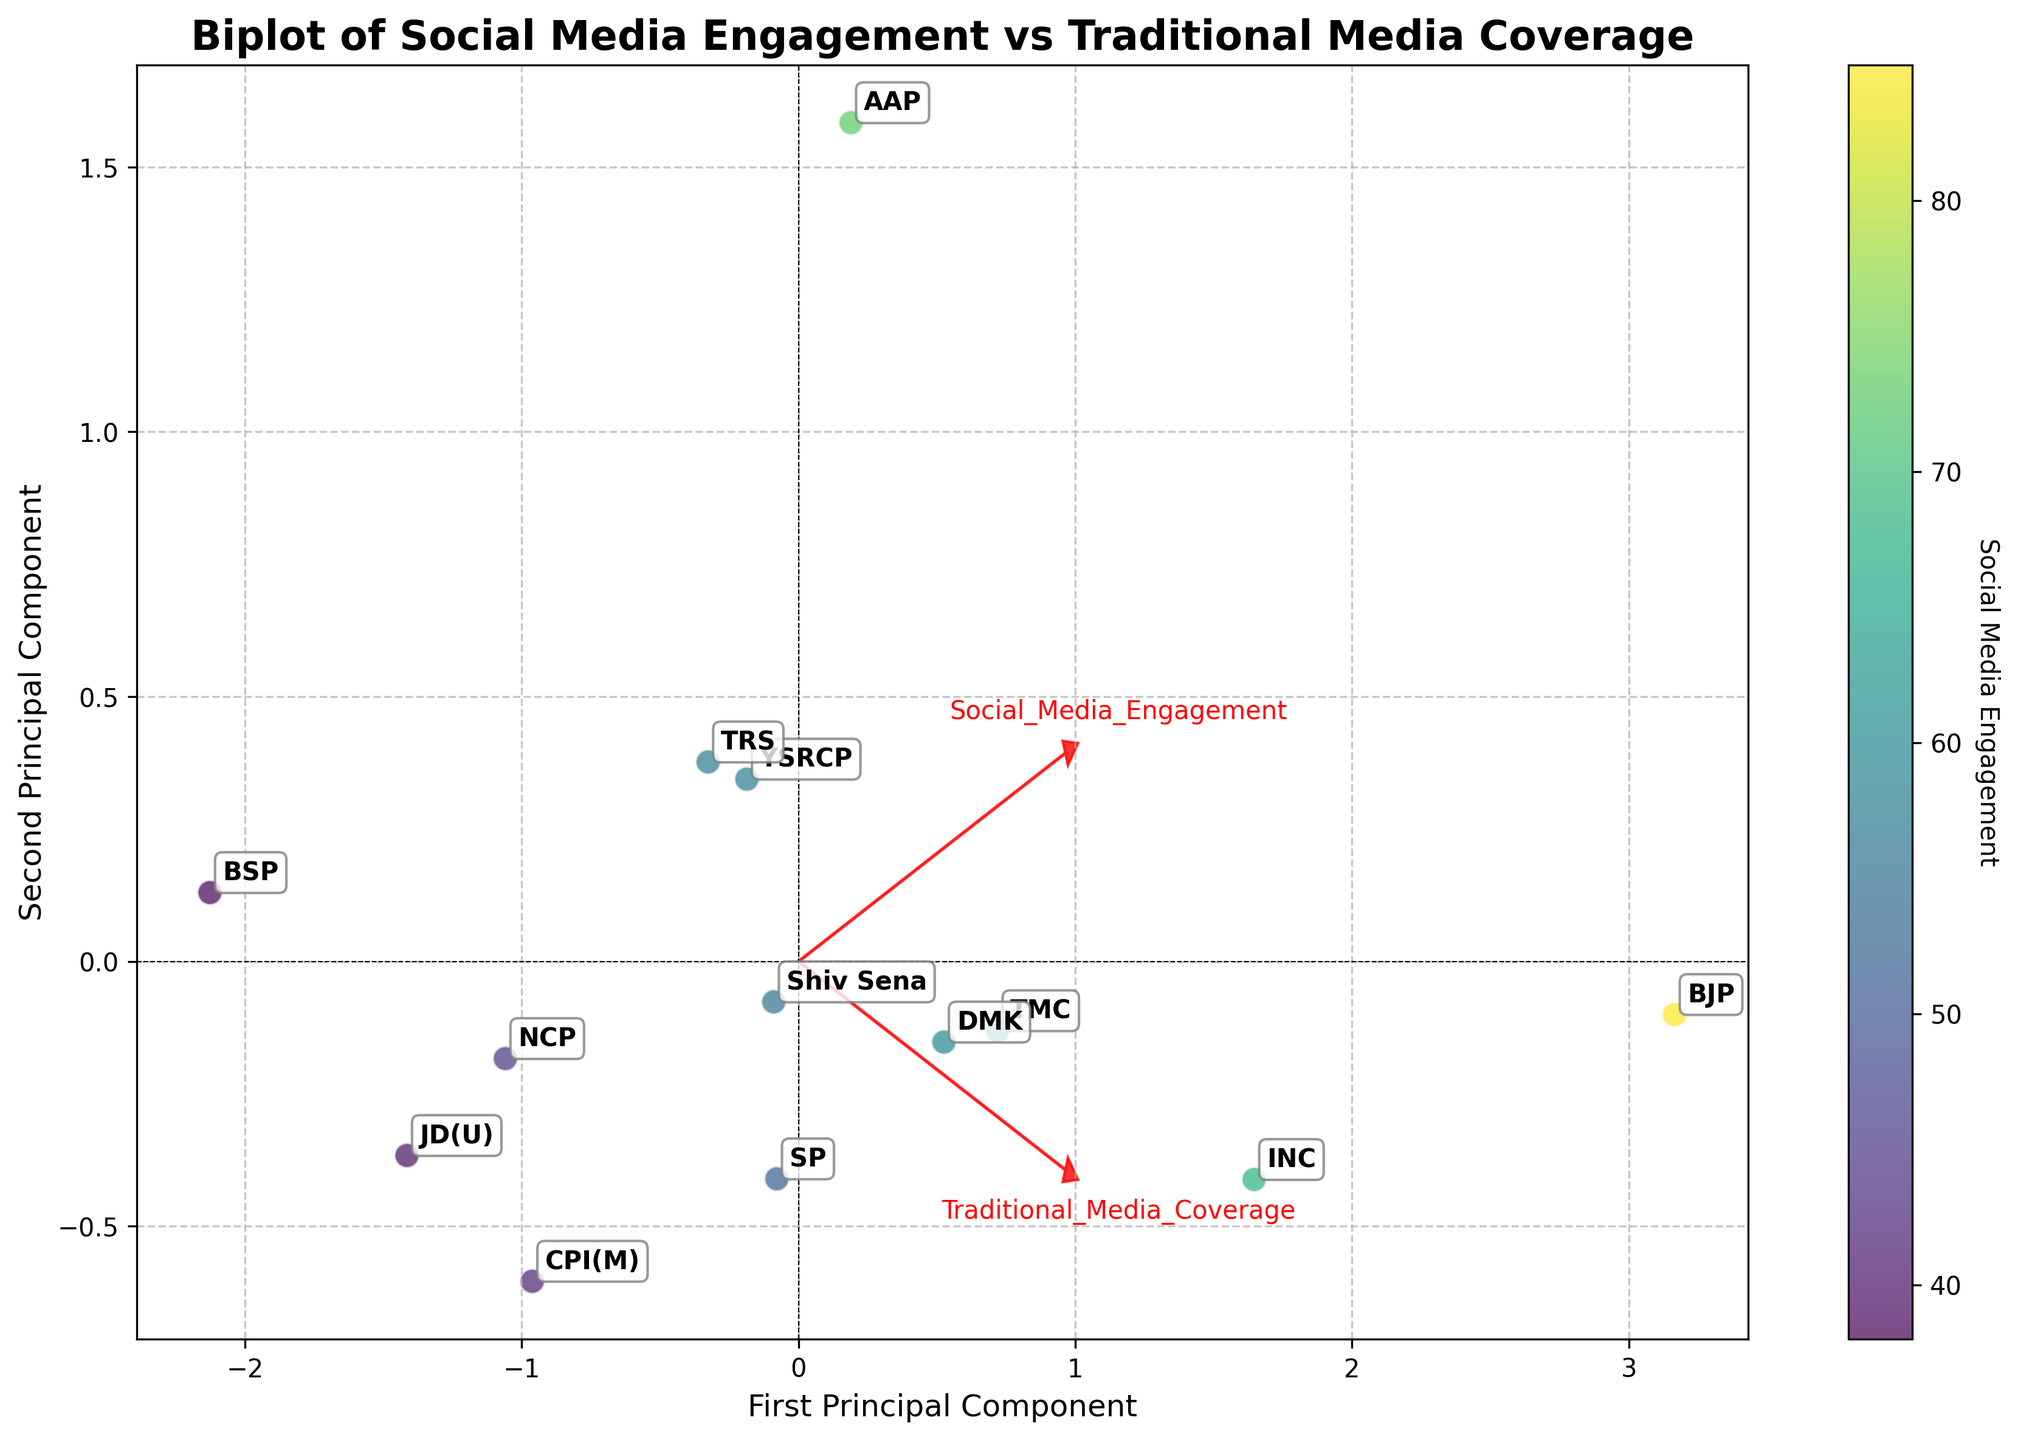What's the title of the biplot? The title is typically found at the top of the plot, which helps to understand the overall subject of the figure. Just look at the top-center part of the plot to identify it.
Answer: Biplot of Social Media Engagement vs Traditional Media Coverage How many political parties are represented in the biplot? To determine the number of political parties, count the number of unique labels or data points represented in the plot.
Answer: 13 Which political party has the highest social media engagement? From the color intensity on the scatter plot, find the data point with the color indicating the highest value on the color bar.
Answer: BJP Which political party has the lowest traditional media coverage? Look at the position along the axis for Traditional Media Coverage and find the data point representing the lowest value.
Answer: BSP Does any party have more social media engagement but less traditional media coverage compared to another? Compare the positions of the data points for different parties on both axes and see if one is higher on Social Media Engagement but lower on Traditional Media Coverage.
Answer: Yes, AAP (more engagement, less coverage compared to INC) Which two parties have the most similar social media engagement and traditional media coverage? Identify data points that are closely positioned to each other on both principal components of the biplot.
Answer: INC and TMC Which principal component mainly represents social media engagement? Identify which loading vector has a large component in the direction where social media engagement increases. The principal component with a significant loading in this direction represents it better.
Answer: The first principal component How can we interpret the position of Shiv Sena in terms of media coverage? Look at Shiv Sena’s position along the principal components and the loading vectors. Compare with other parties and the zero lines to interpret its relative media coverage.
Answer: Moderate social and traditional media coverage What does the loading vector for Traditional Media Coverage indicate about the relation between the principal components and this feature? The direction and length of the loading vector represent how strongly traditional media coverage correlates with each principal component. The closer and longer the arrow aligns with a principal component, the stronger the correlation.
Answer: It has a strong correlation with the second principal component Is there any clear clustering or grouping seen among the parties based on their media engagement? Check for visually identifiable groups or clusters of data points, where multiple points are closely grouped together compared to others.
Answer: No clear clusters 